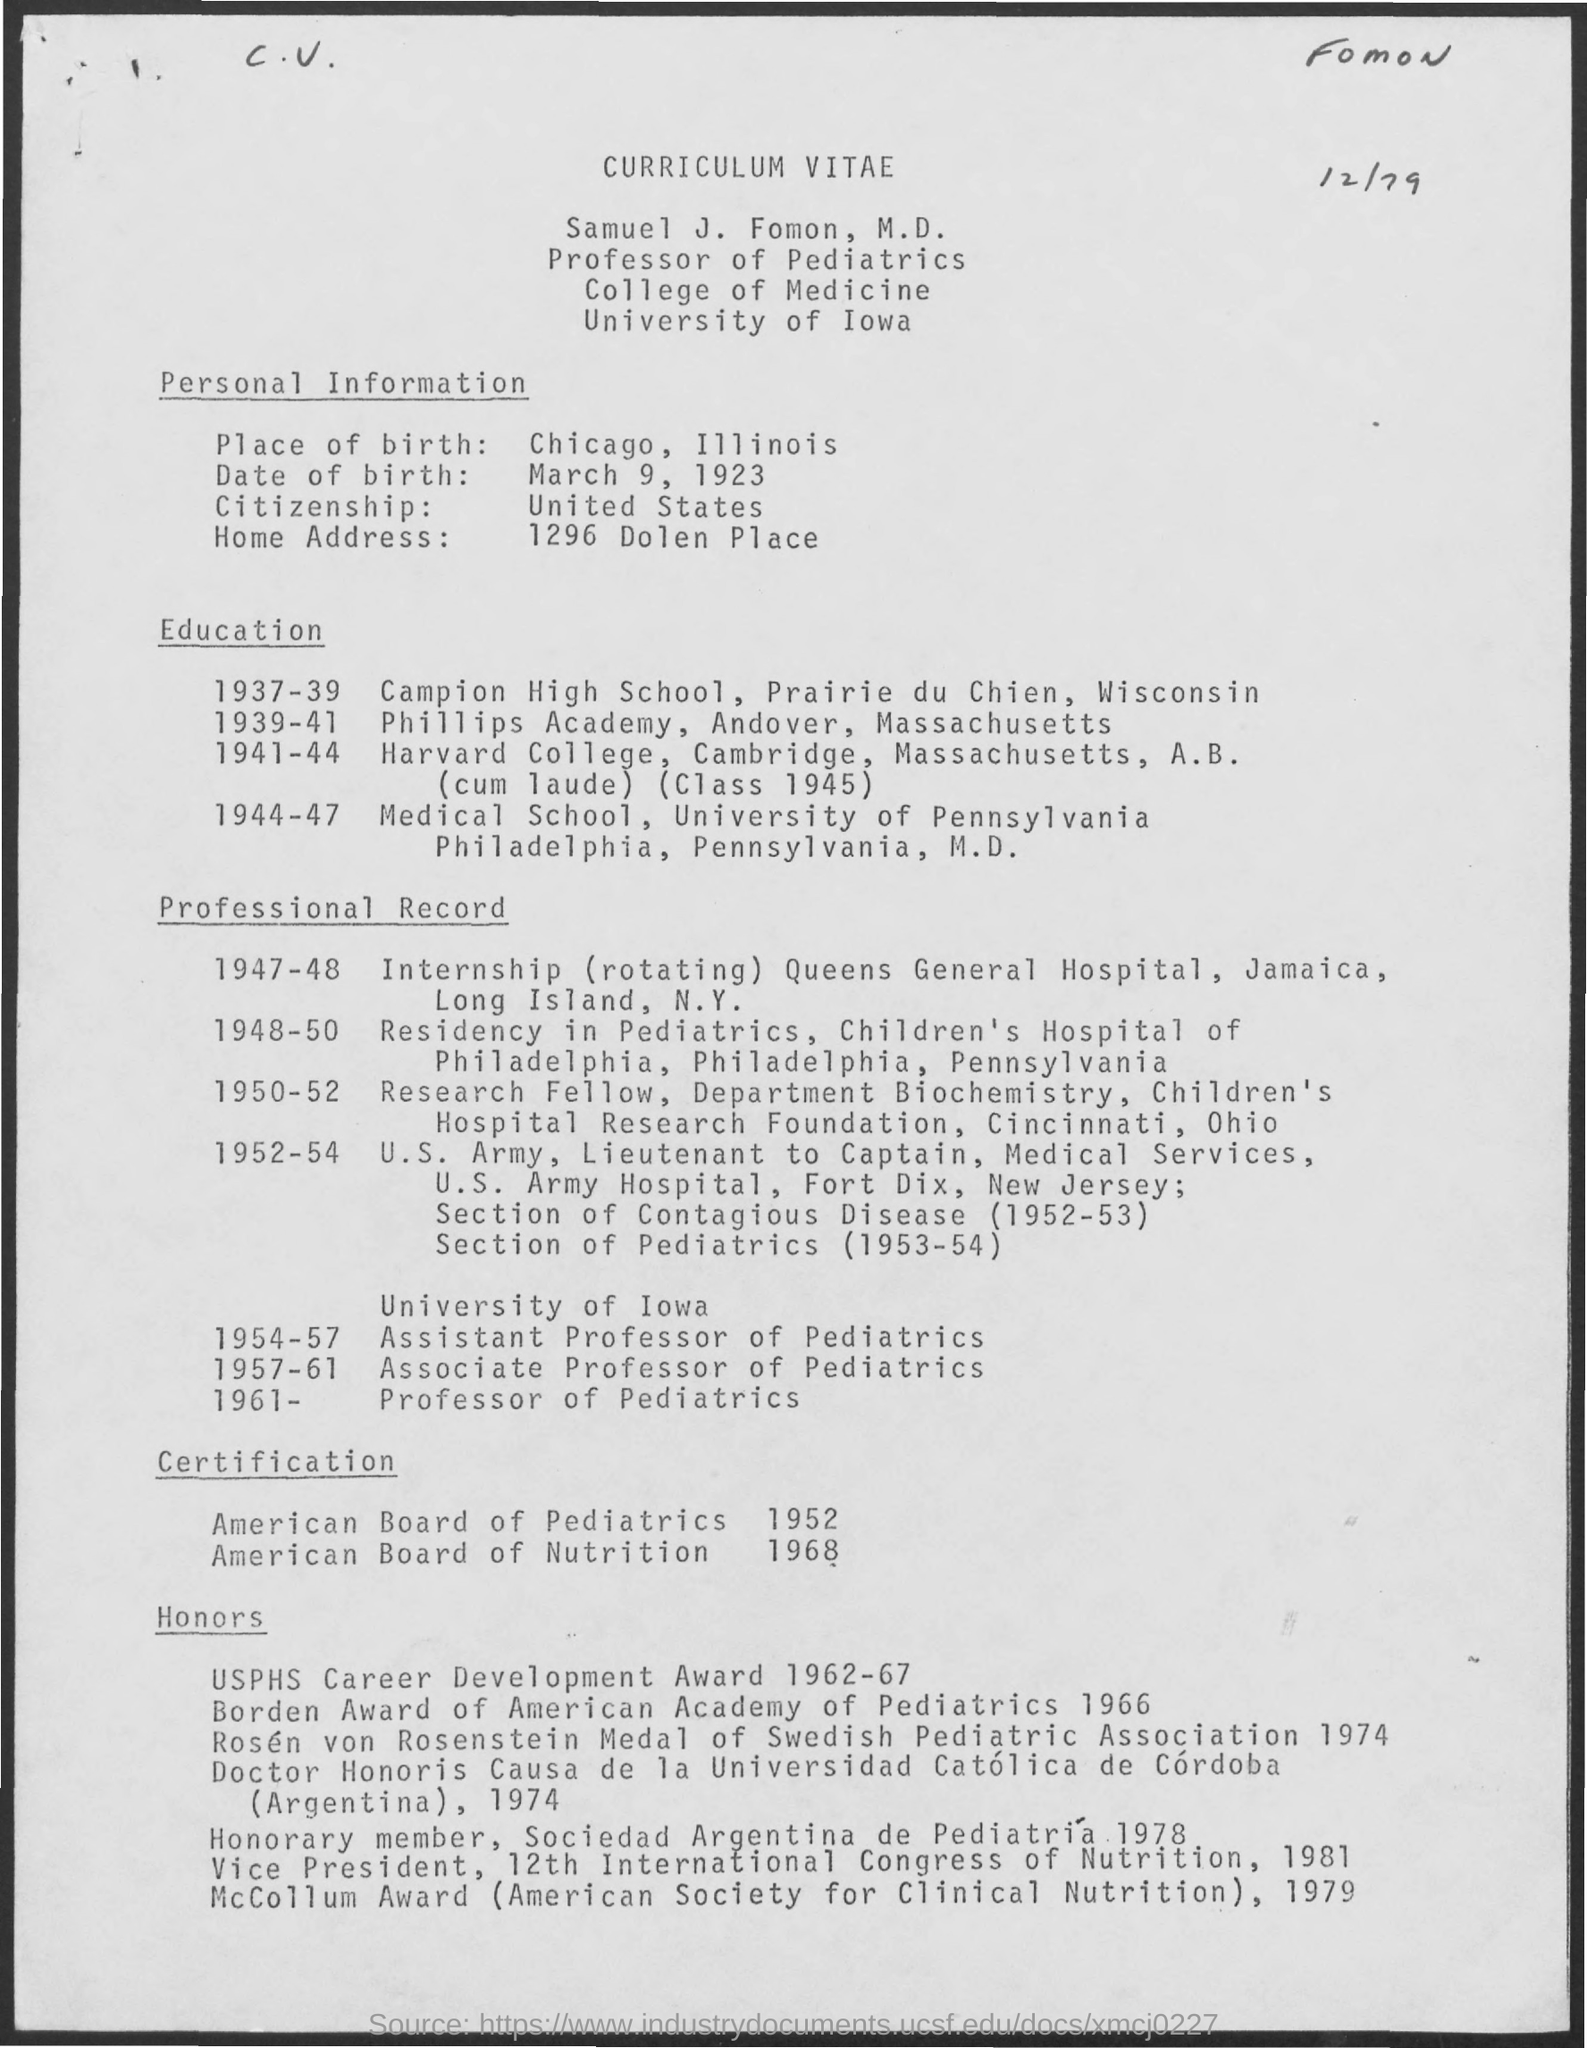What is the Date of Bith of Samuel J. Fomon , M. D.?
Your answer should be very brief. March 9, 1923. What is the Citizenship of Samuel J. Fomon , M. D.?
Provide a short and direct response. United States. In which University, Samuel J. Fomon , M. D. works?
Offer a terse response. University of iowa. What is the Place of Birth of Samuel J. Fomon , M. D.?
Offer a very short reply. Chicago, Illinois. During which period, Samuel J. Fomon , M. D. worked as a Residency in Pediatrics?
Your answer should be compact. 1948-50. When did Samuel J. Fomon , M. D. received certification from American Board of Pediattrics?
Your response must be concise. 1952. What certification is received by  Samuel J. Fomon , M. D. in the year 1968?
Provide a succinct answer. American Board of Nutrition. 